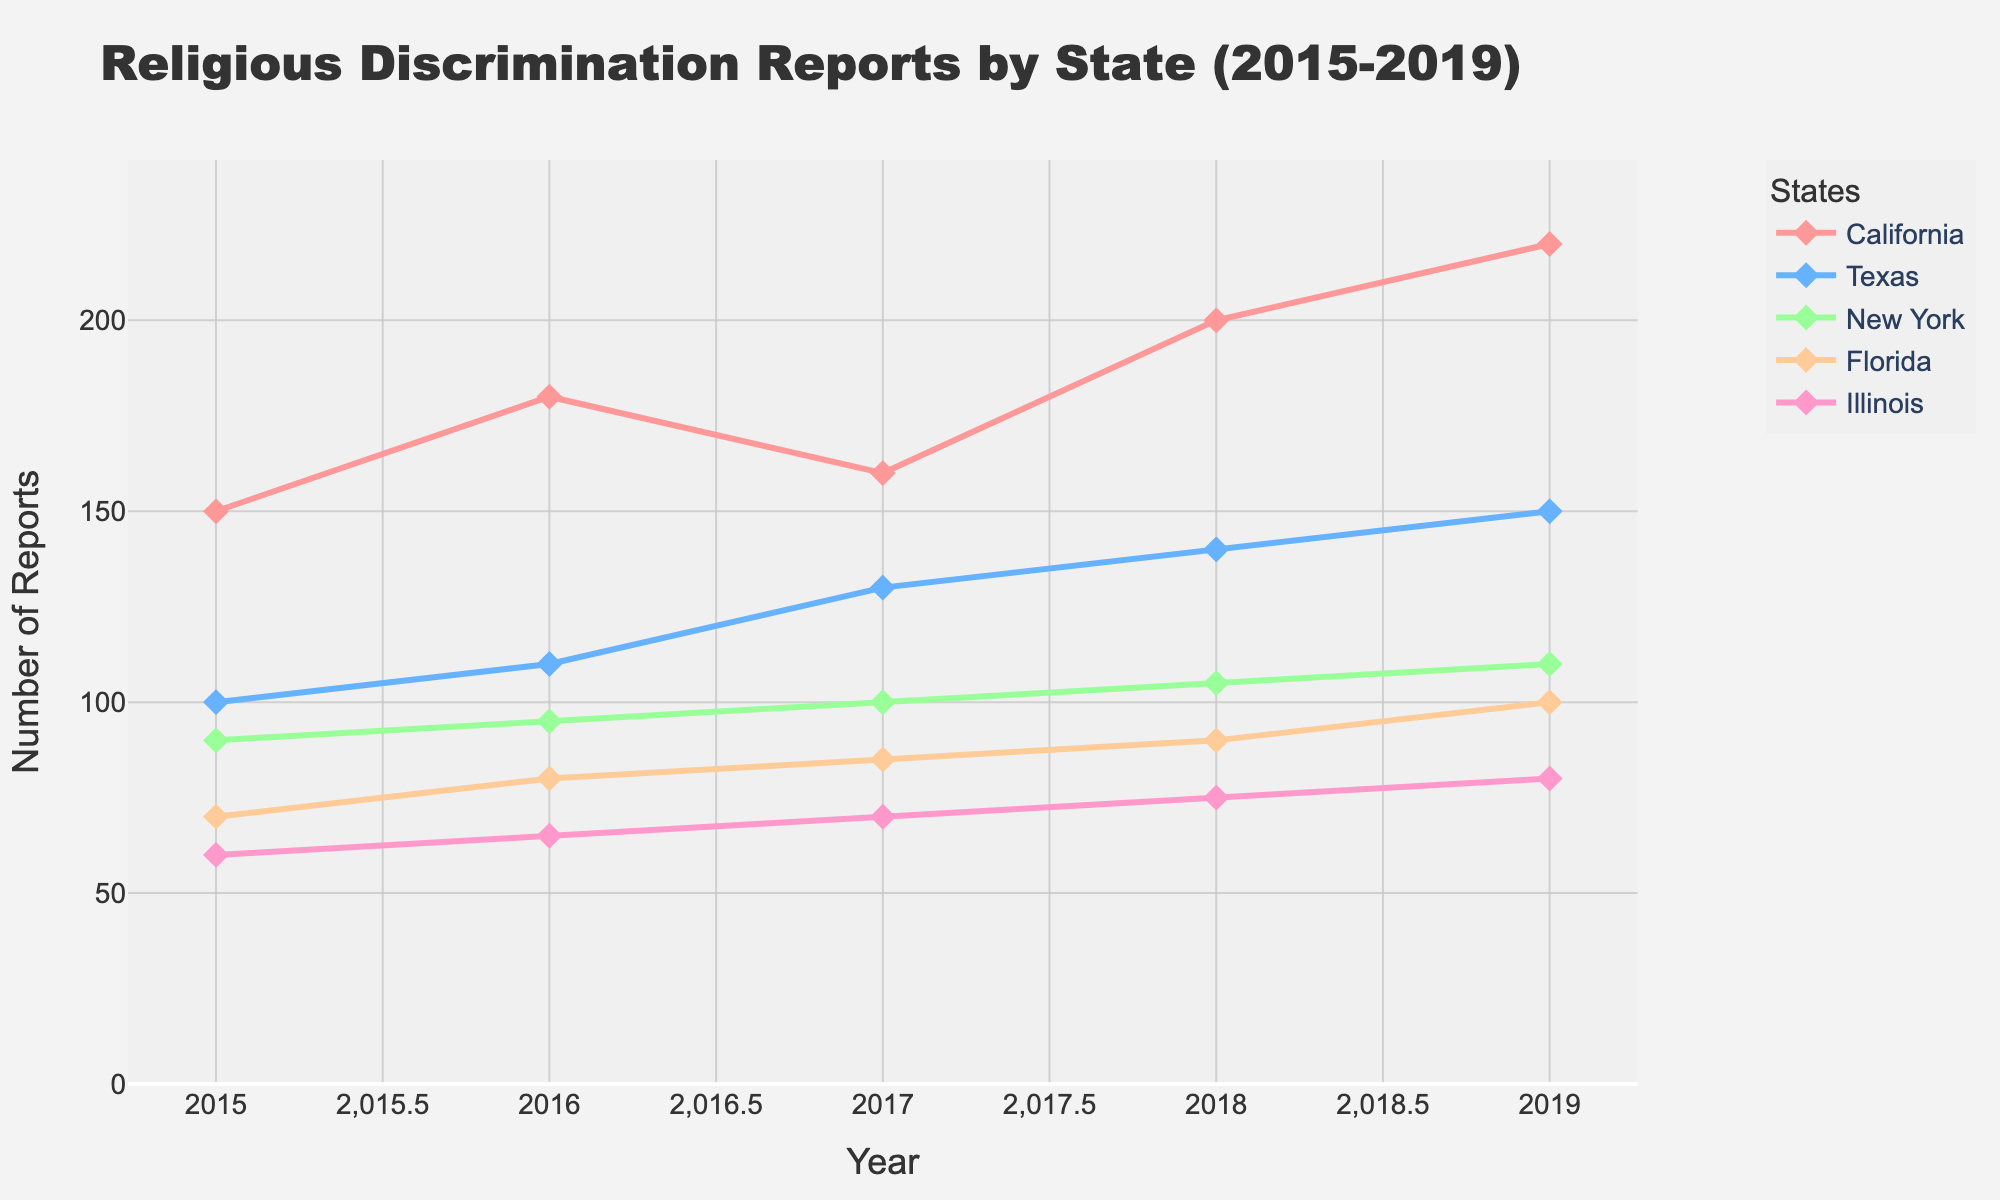What's the title of the plot? The title is typically located at the top of the plot. By looking at that area, we can see the title.
Answer: Religious Discrimination Reports by State (2015-2019) What is the y-axis labeled as? The y-axis label is generally displayed vertically along the y-axis part of the plot. It provides information on what is being measured.
Answer: Number of Reports Which state had the highest number of reports in 2019? By finding the points for the year 2019 on the x-axis and comparing their y-values (Number of Reports) for each state, the state with the highest y-value is the one we're looking for.
Answer: California What was the trend in the number of reports for Texas from 2015 to 2019? The trend can be identified by looking at the plot line for Texas and observing the pattern of change from 2015 to 2019.
Answer: Increasing How many reports did Illinois have in 2017? Find the data point for Illinois in the year 2017 by locating the x-value 2017 and seeing where the Illinois line intersects with this x-value, then check the corresponding y-value.
Answer: 70 Did New York's trend in the number of reports increase or decrease from 2015 to 2019? By examining the plot line for New York from 2015 to 2019, check the direction of the line to determine if it is generally rising or falling.
Answer: Increase What is the average number of reports for Florida from 2015 to 2019? Add the number of reports for Florida from 2015 to 2019 (70 + 80 + 85 + 90 + 100) and then divide by the number of years (5).
Answer: 85 Which state showed the most significant increase in reports from 2017 to 2018? By comparing the differences in y-values between 2017 and 2018 for all states, identify the state with the highest increase in y-value.
Answer: California Between California and Texas, which state had more reports in 2016? Look at the y-values for both California and Texas in the year 2016. The state with the higher y-value had more reports.
Answer: California Did any state experience a decrease in the number of reports in any consecutive years within the period from 2015 to 2019? Examine the plot lines for each state and check if there is a dip in any consecutive years.
Answer: Yes, California from 2016 to 2017 